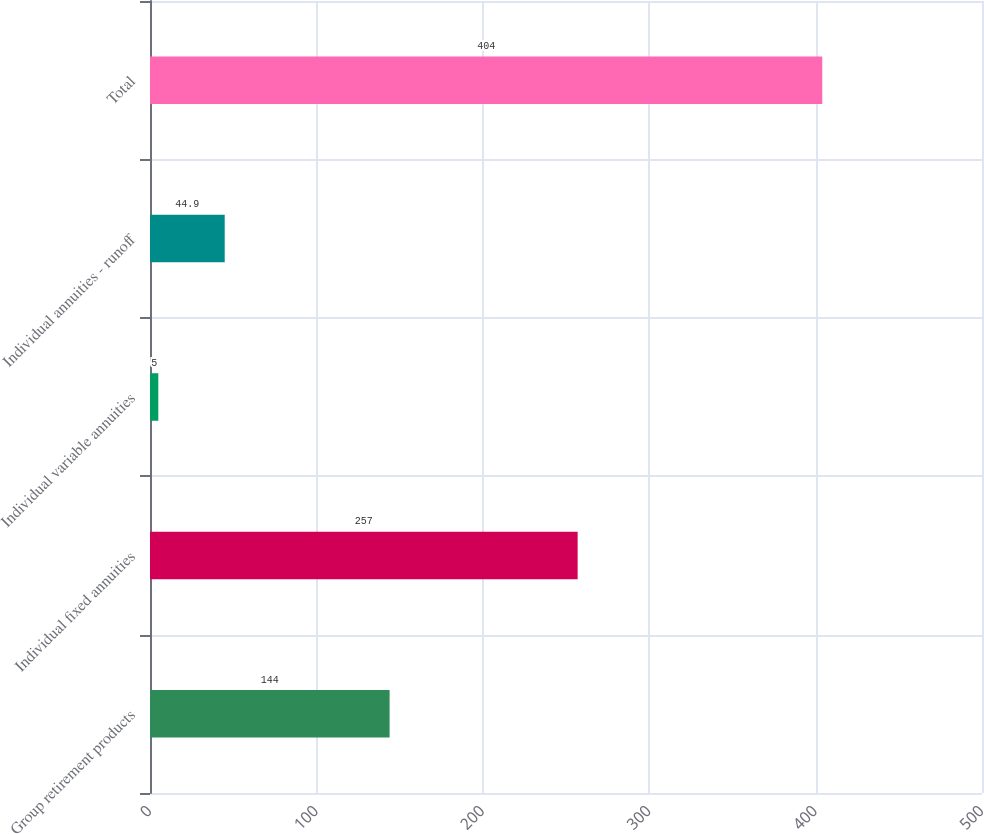Convert chart. <chart><loc_0><loc_0><loc_500><loc_500><bar_chart><fcel>Group retirement products<fcel>Individual fixed annuities<fcel>Individual variable annuities<fcel>Individual annuities - runoff<fcel>Total<nl><fcel>144<fcel>257<fcel>5<fcel>44.9<fcel>404<nl></chart> 